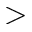<formula> <loc_0><loc_0><loc_500><loc_500>></formula> 